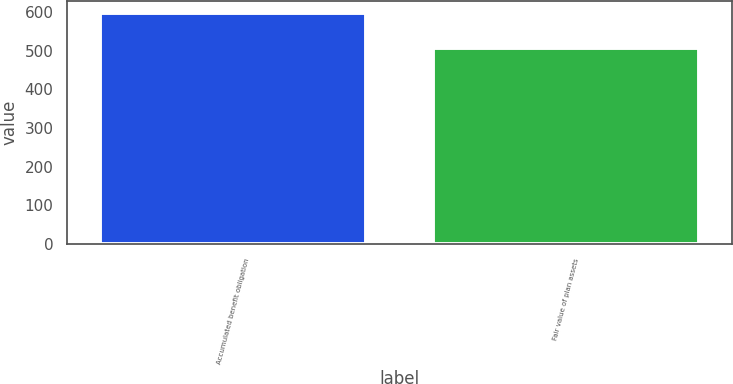Convert chart to OTSL. <chart><loc_0><loc_0><loc_500><loc_500><bar_chart><fcel>Accumulated benefit obligation<fcel>Fair value of plan assets<nl><fcel>599<fcel>508<nl></chart> 